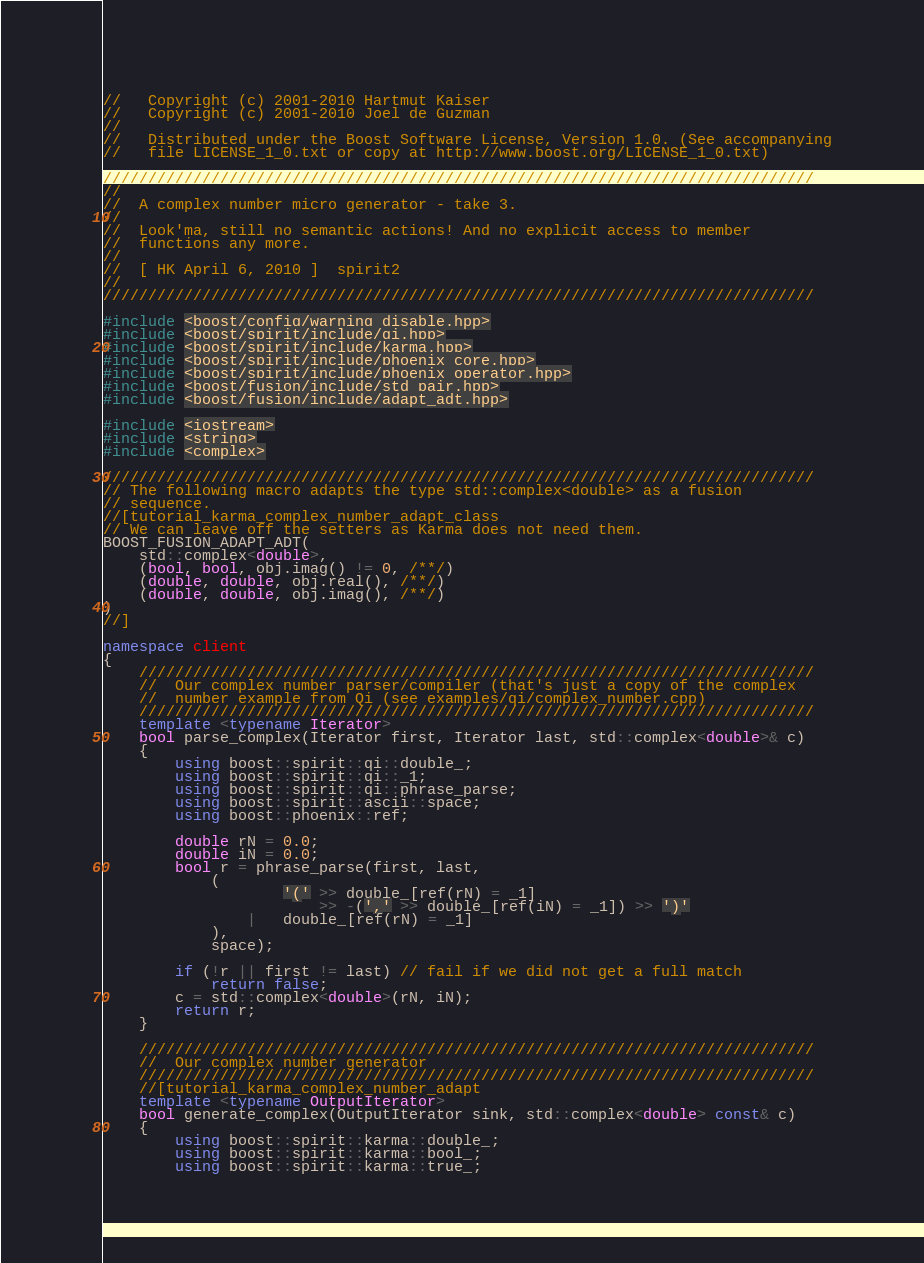<code> <loc_0><loc_0><loc_500><loc_500><_C++_>//   Copyright (c) 2001-2010 Hartmut Kaiser
//   Copyright (c) 2001-2010 Joel de Guzman
// 
//   Distributed under the Boost Software License, Version 1.0. (See accompanying
//   file LICENSE_1_0.txt or copy at http://www.boost.org/LICENSE_1_0.txt)

///////////////////////////////////////////////////////////////////////////////
//
//  A complex number micro generator - take 3. 
// 
//  Look'ma, still no semantic actions! And no explicit access to member 
//  functions any more.
//
//  [ HK April 6, 2010 ]  spirit2
//
///////////////////////////////////////////////////////////////////////////////

#include <boost/config/warning_disable.hpp>
#include <boost/spirit/include/qi.hpp>
#include <boost/spirit/include/karma.hpp>
#include <boost/spirit/include/phoenix_core.hpp>
#include <boost/spirit/include/phoenix_operator.hpp>
#include <boost/fusion/include/std_pair.hpp>
#include <boost/fusion/include/adapt_adt.hpp>

#include <iostream>
#include <string>
#include <complex>

///////////////////////////////////////////////////////////////////////////////
// The following macro adapts the type std::complex<double> as a fusion 
// sequence. 
//[tutorial_karma_complex_number_adapt_class
// We can leave off the setters as Karma does not need them.
BOOST_FUSION_ADAPT_ADT(
    std::complex<double>,
    (bool, bool, obj.imag() != 0, /**/)
    (double, double, obj.real(), /**/)
    (double, double, obj.imag(), /**/)
)
//]

namespace client
{
    ///////////////////////////////////////////////////////////////////////////
    //  Our complex number parser/compiler (that's just a copy of the complex 
    //  number example from Qi (see examples/qi/complex_number.cpp)
    ///////////////////////////////////////////////////////////////////////////
    template <typename Iterator>
    bool parse_complex(Iterator first, Iterator last, std::complex<double>& c)
    {
        using boost::spirit::qi::double_;
        using boost::spirit::qi::_1;
        using boost::spirit::qi::phrase_parse;
        using boost::spirit::ascii::space;
        using boost::phoenix::ref;

        double rN = 0.0;
        double iN = 0.0;
        bool r = phrase_parse(first, last,
            (
                    '(' >> double_[ref(rN) = _1]
                        >> -(',' >> double_[ref(iN) = _1]) >> ')'
                |   double_[ref(rN) = _1]
            ),
            space);

        if (!r || first != last) // fail if we did not get a full match
            return false;
        c = std::complex<double>(rN, iN);
        return r;
    }

    ///////////////////////////////////////////////////////////////////////////
    //  Our complex number generator
    ///////////////////////////////////////////////////////////////////////////
    //[tutorial_karma_complex_number_adapt
    template <typename OutputIterator>
    bool generate_complex(OutputIterator sink, std::complex<double> const& c)
    {
        using boost::spirit::karma::double_;
        using boost::spirit::karma::bool_;
        using boost::spirit::karma::true_;</code> 